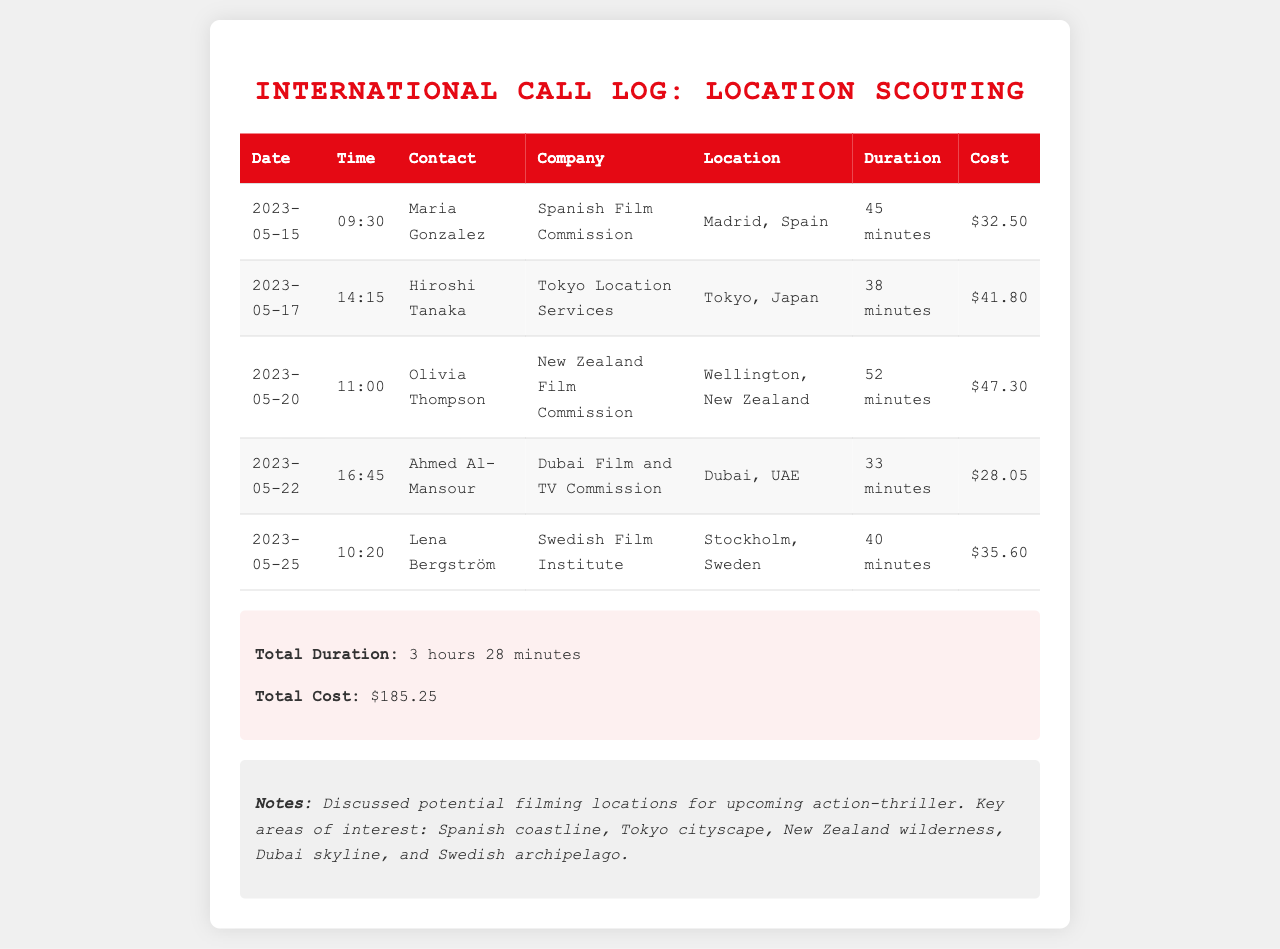What is the total cost of all calls? The total cost is listed in the summary section of the document, representing the sum of costs from all calls: $32.50 + $41.80 + $47.30 + $28.05 + $35.60 = $185.25.
Answer: $185.25 Who is the contact for the Dubai Film and TV Commission? The document lists Ahmed Al-Mansour as the contact for the Dubai Film and TV Commission under the respective row.
Answer: Ahmed Al-Mansour What is the duration of the call with Olivia Thompson? The document specifies the duration for the call with Olivia Thompson, which is presented in the table under the duration column.
Answer: 52 minutes How many minutes was spent on calls to Tokyo and Dubai combined? To find the combined duration, add the minutes from both calls: 38 minutes (Tokyo) + 33 minutes (Dubai) = 71 minutes.
Answer: 71 minutes What location is being scouted in Sweden? The table indicates that the location being scouted in Sweden is Stockholm as mentioned in the corresponding row.
Answer: Stockholm What date was the call made to Maria Gonzalez? The date for the call to Maria Gonzalez is shown in the table under the date column.
Answer: 2023-05-15 How many calls did I make in total? The document includes five rows of call details, each representing one call, indicating the total number of calls made.
Answer: 5 calls What is the common theme discussed in the notes? The notes summarize that filming locations were discussed for an upcoming action-thriller, reflecting the overarching topic.
Answer: Filming locations 